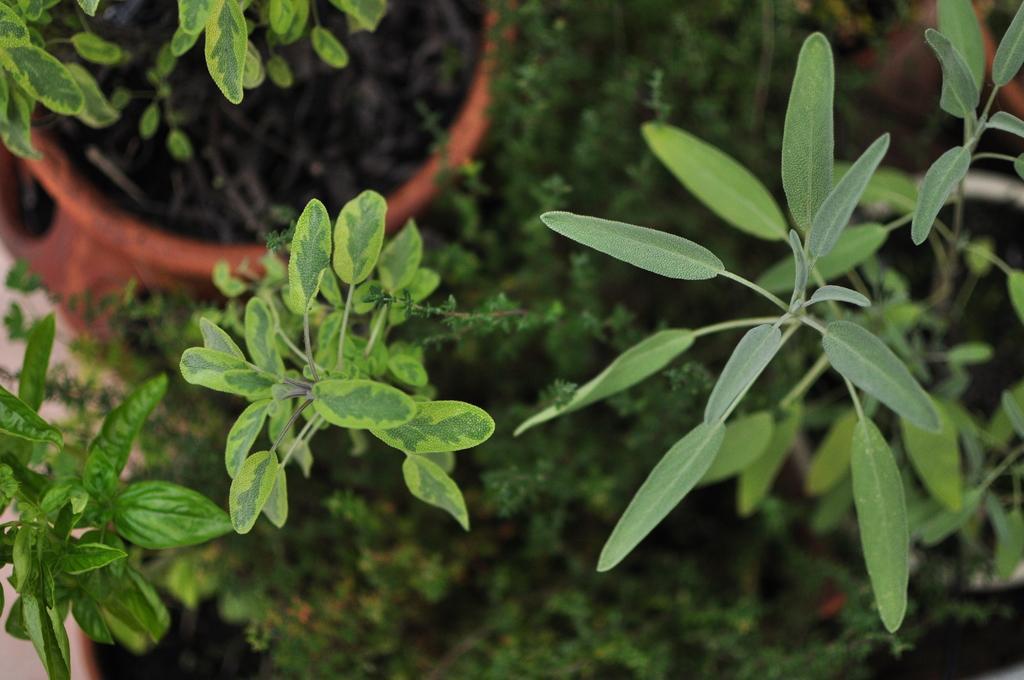Can you describe this image briefly? As we can see in the image there are plants and pot. 